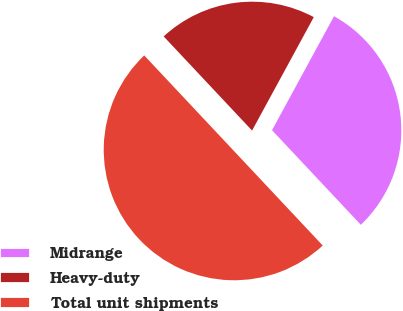Convert chart to OTSL. <chart><loc_0><loc_0><loc_500><loc_500><pie_chart><fcel>Midrange<fcel>Heavy-duty<fcel>Total unit shipments<nl><fcel>30.07%<fcel>19.93%<fcel>50.0%<nl></chart> 